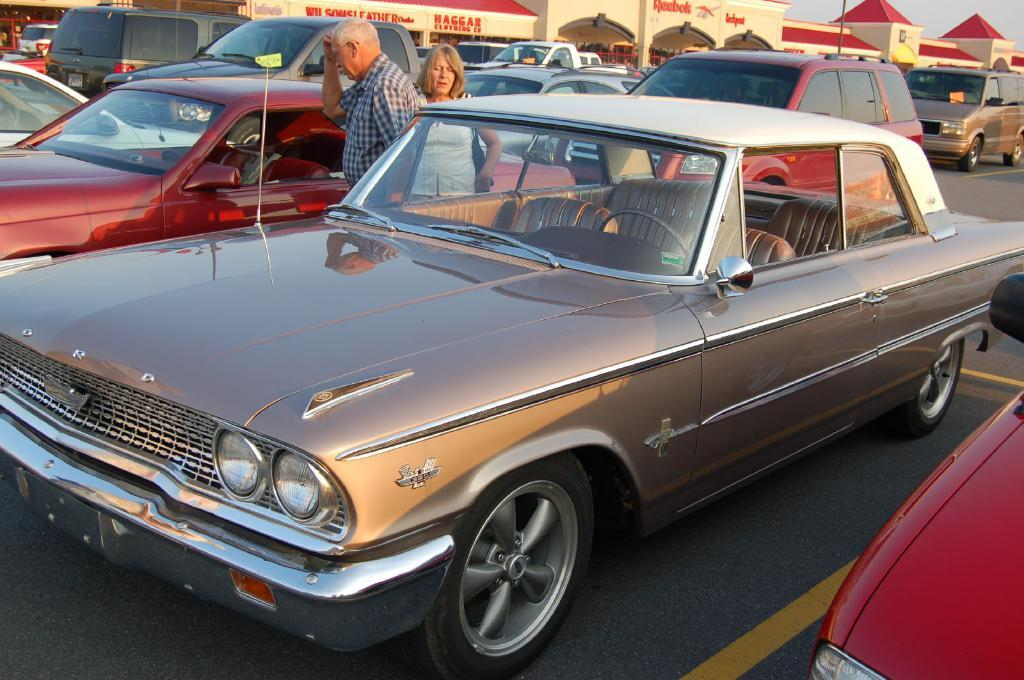What can be seen on the road in the image? There are vehicles on the road in the image. How many people are standing in the image? Two persons are standing in the image. What is visible in the background of the image? There are buildings, hoardings, roofs, and the sky visible in the background of the image. What type of card is being played by the persons in the image? There is no card or card game present in the image. What record is being set by the vehicles on the road in the image? There is no record being set by the vehicles in the image; they are simply driving on the road. 